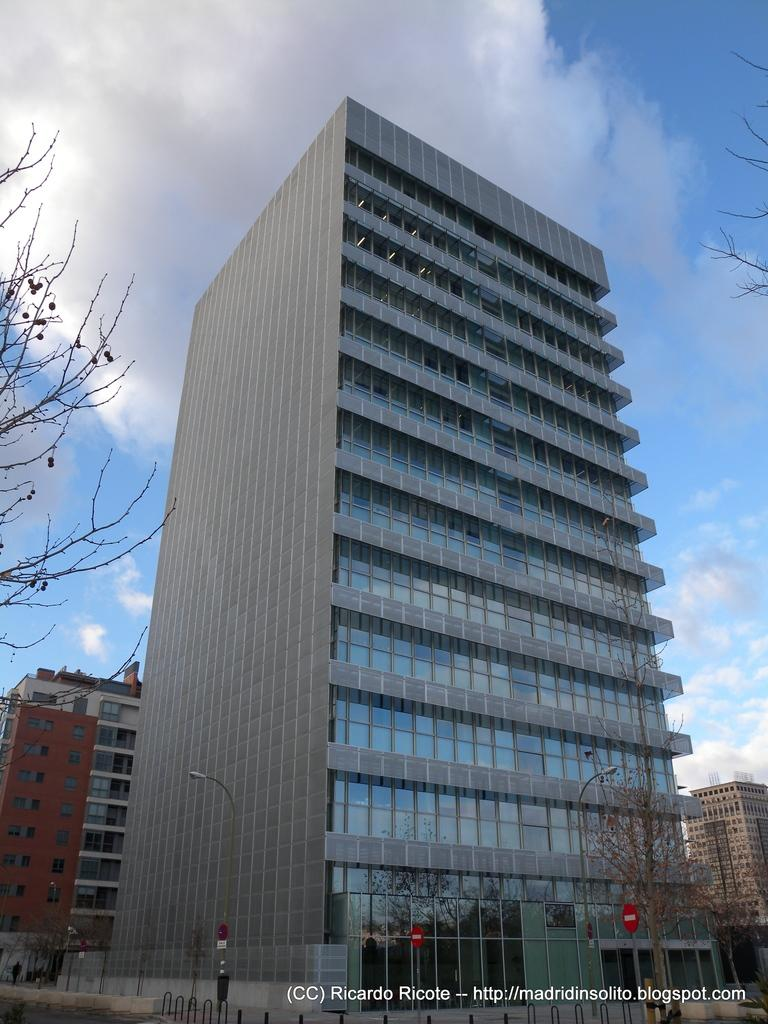What type of structures can be seen in the image? There are buildings in the image. What other natural elements are present in the image? There are trees in the image. Where is the text located in the image? The text is at the bottom right corner of the image. How would you describe the sky in the image? The sky is blue and cloudy in the image. What type of verse can be heard being recited by the crook in the image? There is no crook or verse present in the image. 